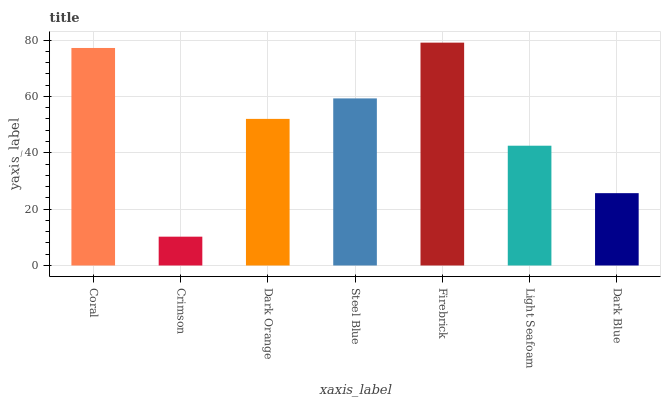Is Crimson the minimum?
Answer yes or no. Yes. Is Firebrick the maximum?
Answer yes or no. Yes. Is Dark Orange the minimum?
Answer yes or no. No. Is Dark Orange the maximum?
Answer yes or no. No. Is Dark Orange greater than Crimson?
Answer yes or no. Yes. Is Crimson less than Dark Orange?
Answer yes or no. Yes. Is Crimson greater than Dark Orange?
Answer yes or no. No. Is Dark Orange less than Crimson?
Answer yes or no. No. Is Dark Orange the high median?
Answer yes or no. Yes. Is Dark Orange the low median?
Answer yes or no. Yes. Is Dark Blue the high median?
Answer yes or no. No. Is Firebrick the low median?
Answer yes or no. No. 